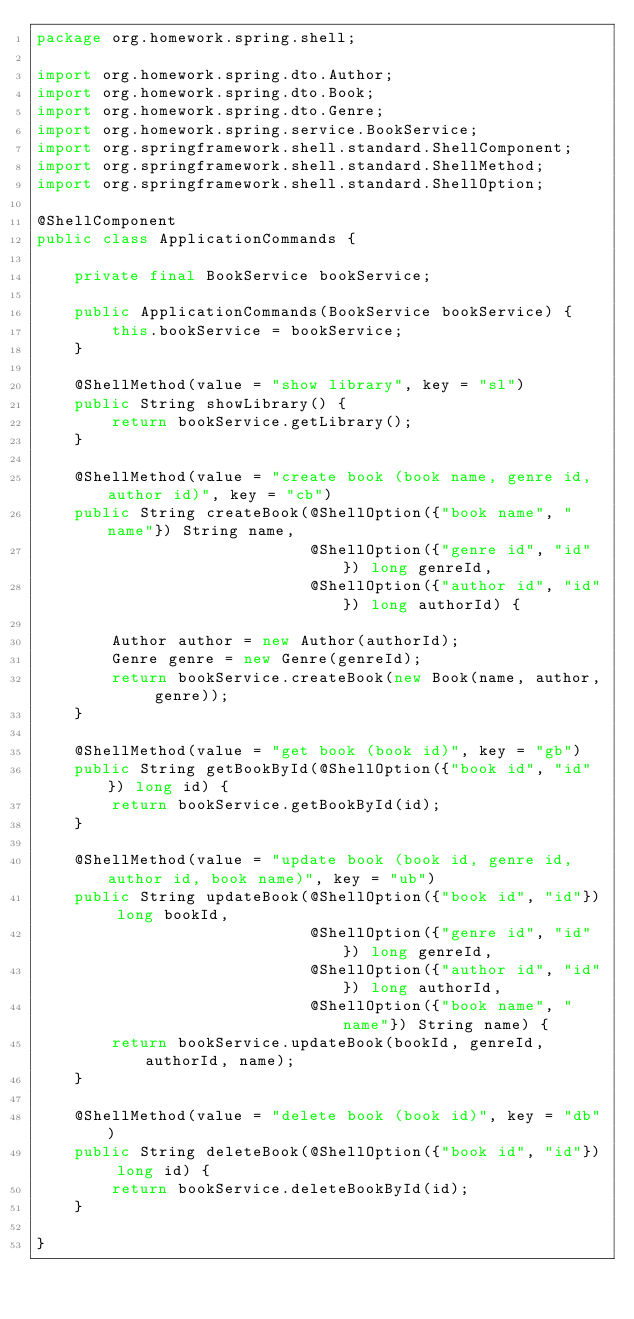Convert code to text. <code><loc_0><loc_0><loc_500><loc_500><_Java_>package org.homework.spring.shell;

import org.homework.spring.dto.Author;
import org.homework.spring.dto.Book;
import org.homework.spring.dto.Genre;
import org.homework.spring.service.BookService;
import org.springframework.shell.standard.ShellComponent;
import org.springframework.shell.standard.ShellMethod;
import org.springframework.shell.standard.ShellOption;

@ShellComponent
public class ApplicationCommands {

    private final BookService bookService;

    public ApplicationCommands(BookService bookService) {
        this.bookService = bookService;
    }

    @ShellMethod(value = "show library", key = "sl")
    public String showLibrary() {
        return bookService.getLibrary();
    }

    @ShellMethod(value = "create book (book name, genre id, author id)", key = "cb")
    public String createBook(@ShellOption({"book name", "name"}) String name,
                             @ShellOption({"genre id", "id"}) long genreId,
                             @ShellOption({"author id", "id"}) long authorId) {

        Author author = new Author(authorId);
        Genre genre = new Genre(genreId);
        return bookService.createBook(new Book(name, author, genre));
    }

    @ShellMethod(value = "get book (book id)", key = "gb")
    public String getBookById(@ShellOption({"book id", "id"}) long id) {
        return bookService.getBookById(id);
    }

    @ShellMethod(value = "update book (book id, genre id, author id, book name)", key = "ub")
    public String updateBook(@ShellOption({"book id", "id"}) long bookId,
                             @ShellOption({"genre id", "id"}) long genreId,
                             @ShellOption({"author id", "id"}) long authorId,
                             @ShellOption({"book name", "name"}) String name) {
        return bookService.updateBook(bookId, genreId, authorId, name);
    }

    @ShellMethod(value = "delete book (book id)", key = "db")
    public String deleteBook(@ShellOption({"book id", "id"}) long id) {
        return bookService.deleteBookById(id);
    }

}</code> 